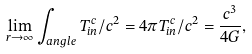<formula> <loc_0><loc_0><loc_500><loc_500>\lim _ { r \rightarrow \infty } \int _ { a n g l e } T _ { i n } ^ { c } / c ^ { 2 } = 4 \pi T _ { i n } ^ { c } / c ^ { 2 } = \frac { c ^ { 3 } } { 4 G } ,</formula> 